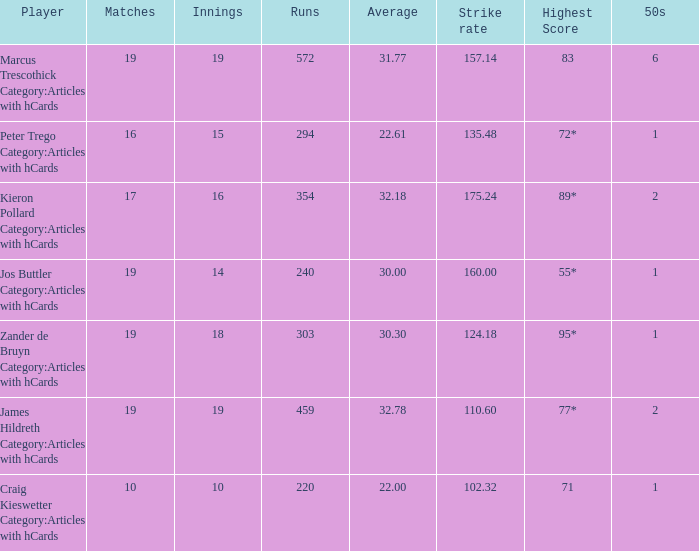What is the strike rate for the player with an average of 32.78? 110.6. 